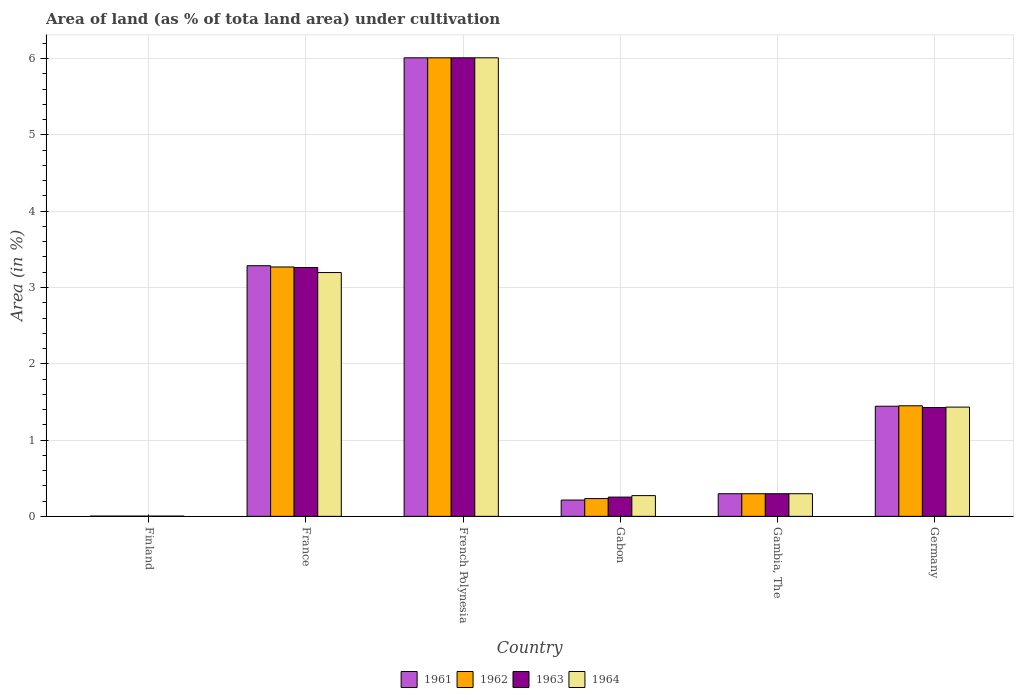What is the label of the 4th group of bars from the left?
Provide a succinct answer. Gabon. In how many cases, is the number of bars for a given country not equal to the number of legend labels?
Keep it short and to the point. 0. What is the percentage of land under cultivation in 1962 in French Polynesia?
Ensure brevity in your answer.  6.01. Across all countries, what is the maximum percentage of land under cultivation in 1964?
Provide a succinct answer. 6.01. Across all countries, what is the minimum percentage of land under cultivation in 1963?
Give a very brief answer. 0. In which country was the percentage of land under cultivation in 1961 maximum?
Provide a succinct answer. French Polynesia. In which country was the percentage of land under cultivation in 1964 minimum?
Give a very brief answer. Finland. What is the total percentage of land under cultivation in 1961 in the graph?
Provide a short and direct response. 11.25. What is the difference between the percentage of land under cultivation in 1961 in French Polynesia and that in Germany?
Offer a terse response. 4.57. What is the difference between the percentage of land under cultivation in 1962 in Finland and the percentage of land under cultivation in 1964 in French Polynesia?
Offer a terse response. -6.01. What is the average percentage of land under cultivation in 1962 per country?
Provide a short and direct response. 1.88. In how many countries, is the percentage of land under cultivation in 1961 greater than 0.2 %?
Offer a terse response. 5. What is the ratio of the percentage of land under cultivation in 1961 in Finland to that in Germany?
Your answer should be very brief. 0. Is the difference between the percentage of land under cultivation in 1964 in France and Germany greater than the difference between the percentage of land under cultivation in 1963 in France and Germany?
Offer a very short reply. No. What is the difference between the highest and the second highest percentage of land under cultivation in 1961?
Provide a short and direct response. -1.84. What is the difference between the highest and the lowest percentage of land under cultivation in 1961?
Offer a very short reply. 6.01. How many bars are there?
Keep it short and to the point. 24. Are all the bars in the graph horizontal?
Your answer should be very brief. No. How many countries are there in the graph?
Your response must be concise. 6. Does the graph contain any zero values?
Your response must be concise. No. How many legend labels are there?
Your answer should be compact. 4. What is the title of the graph?
Offer a very short reply. Area of land (as % of tota land area) under cultivation. Does "2013" appear as one of the legend labels in the graph?
Your answer should be compact. No. What is the label or title of the Y-axis?
Offer a very short reply. Area (in %). What is the Area (in %) of 1961 in Finland?
Your response must be concise. 0. What is the Area (in %) of 1962 in Finland?
Offer a very short reply. 0. What is the Area (in %) of 1963 in Finland?
Make the answer very short. 0. What is the Area (in %) in 1964 in Finland?
Give a very brief answer. 0. What is the Area (in %) in 1961 in France?
Provide a succinct answer. 3.29. What is the Area (in %) in 1962 in France?
Give a very brief answer. 3.27. What is the Area (in %) in 1963 in France?
Your response must be concise. 3.26. What is the Area (in %) of 1964 in France?
Your answer should be very brief. 3.2. What is the Area (in %) in 1961 in French Polynesia?
Offer a very short reply. 6.01. What is the Area (in %) in 1962 in French Polynesia?
Your answer should be very brief. 6.01. What is the Area (in %) of 1963 in French Polynesia?
Give a very brief answer. 6.01. What is the Area (in %) in 1964 in French Polynesia?
Give a very brief answer. 6.01. What is the Area (in %) in 1961 in Gabon?
Ensure brevity in your answer.  0.21. What is the Area (in %) of 1962 in Gabon?
Your response must be concise. 0.23. What is the Area (in %) of 1963 in Gabon?
Your response must be concise. 0.25. What is the Area (in %) of 1964 in Gabon?
Make the answer very short. 0.27. What is the Area (in %) of 1961 in Gambia, The?
Your answer should be compact. 0.3. What is the Area (in %) in 1962 in Gambia, The?
Your response must be concise. 0.3. What is the Area (in %) of 1963 in Gambia, The?
Your answer should be compact. 0.3. What is the Area (in %) of 1964 in Gambia, The?
Make the answer very short. 0.3. What is the Area (in %) in 1961 in Germany?
Offer a very short reply. 1.44. What is the Area (in %) of 1962 in Germany?
Provide a succinct answer. 1.45. What is the Area (in %) in 1963 in Germany?
Your answer should be very brief. 1.43. What is the Area (in %) in 1964 in Germany?
Ensure brevity in your answer.  1.43. Across all countries, what is the maximum Area (in %) in 1961?
Provide a succinct answer. 6.01. Across all countries, what is the maximum Area (in %) of 1962?
Give a very brief answer. 6.01. Across all countries, what is the maximum Area (in %) in 1963?
Make the answer very short. 6.01. Across all countries, what is the maximum Area (in %) of 1964?
Give a very brief answer. 6.01. Across all countries, what is the minimum Area (in %) in 1961?
Make the answer very short. 0. Across all countries, what is the minimum Area (in %) in 1962?
Offer a very short reply. 0. Across all countries, what is the minimum Area (in %) in 1963?
Keep it short and to the point. 0. Across all countries, what is the minimum Area (in %) of 1964?
Make the answer very short. 0. What is the total Area (in %) of 1961 in the graph?
Your answer should be very brief. 11.25. What is the total Area (in %) in 1962 in the graph?
Offer a terse response. 11.26. What is the total Area (in %) of 1963 in the graph?
Offer a terse response. 11.25. What is the total Area (in %) in 1964 in the graph?
Make the answer very short. 11.21. What is the difference between the Area (in %) in 1961 in Finland and that in France?
Offer a terse response. -3.28. What is the difference between the Area (in %) of 1962 in Finland and that in France?
Your answer should be very brief. -3.27. What is the difference between the Area (in %) in 1963 in Finland and that in France?
Offer a very short reply. -3.26. What is the difference between the Area (in %) of 1964 in Finland and that in France?
Your answer should be compact. -3.19. What is the difference between the Area (in %) in 1961 in Finland and that in French Polynesia?
Your response must be concise. -6.01. What is the difference between the Area (in %) in 1962 in Finland and that in French Polynesia?
Your response must be concise. -6.01. What is the difference between the Area (in %) in 1963 in Finland and that in French Polynesia?
Ensure brevity in your answer.  -6.01. What is the difference between the Area (in %) in 1964 in Finland and that in French Polynesia?
Give a very brief answer. -6.01. What is the difference between the Area (in %) of 1961 in Finland and that in Gabon?
Make the answer very short. -0.21. What is the difference between the Area (in %) in 1962 in Finland and that in Gabon?
Provide a succinct answer. -0.23. What is the difference between the Area (in %) of 1963 in Finland and that in Gabon?
Provide a short and direct response. -0.25. What is the difference between the Area (in %) in 1964 in Finland and that in Gabon?
Offer a very short reply. -0.27. What is the difference between the Area (in %) of 1961 in Finland and that in Gambia, The?
Your answer should be compact. -0.29. What is the difference between the Area (in %) in 1962 in Finland and that in Gambia, The?
Provide a succinct answer. -0.29. What is the difference between the Area (in %) of 1963 in Finland and that in Gambia, The?
Keep it short and to the point. -0.29. What is the difference between the Area (in %) in 1964 in Finland and that in Gambia, The?
Your answer should be very brief. -0.29. What is the difference between the Area (in %) of 1961 in Finland and that in Germany?
Provide a succinct answer. -1.44. What is the difference between the Area (in %) of 1962 in Finland and that in Germany?
Provide a short and direct response. -1.45. What is the difference between the Area (in %) of 1963 in Finland and that in Germany?
Give a very brief answer. -1.42. What is the difference between the Area (in %) of 1964 in Finland and that in Germany?
Ensure brevity in your answer.  -1.43. What is the difference between the Area (in %) in 1961 in France and that in French Polynesia?
Give a very brief answer. -2.73. What is the difference between the Area (in %) in 1962 in France and that in French Polynesia?
Your response must be concise. -2.74. What is the difference between the Area (in %) in 1963 in France and that in French Polynesia?
Offer a terse response. -2.75. What is the difference between the Area (in %) in 1964 in France and that in French Polynesia?
Your answer should be very brief. -2.81. What is the difference between the Area (in %) in 1961 in France and that in Gabon?
Keep it short and to the point. 3.07. What is the difference between the Area (in %) in 1962 in France and that in Gabon?
Give a very brief answer. 3.04. What is the difference between the Area (in %) in 1963 in France and that in Gabon?
Ensure brevity in your answer.  3.01. What is the difference between the Area (in %) of 1964 in France and that in Gabon?
Give a very brief answer. 2.92. What is the difference between the Area (in %) in 1961 in France and that in Gambia, The?
Your answer should be compact. 2.99. What is the difference between the Area (in %) of 1962 in France and that in Gambia, The?
Provide a short and direct response. 2.97. What is the difference between the Area (in %) in 1963 in France and that in Gambia, The?
Ensure brevity in your answer.  2.97. What is the difference between the Area (in %) of 1964 in France and that in Gambia, The?
Your response must be concise. 2.9. What is the difference between the Area (in %) in 1961 in France and that in Germany?
Your response must be concise. 1.84. What is the difference between the Area (in %) of 1962 in France and that in Germany?
Your answer should be compact. 1.82. What is the difference between the Area (in %) of 1963 in France and that in Germany?
Provide a short and direct response. 1.84. What is the difference between the Area (in %) of 1964 in France and that in Germany?
Offer a very short reply. 1.76. What is the difference between the Area (in %) of 1961 in French Polynesia and that in Gabon?
Your answer should be compact. 5.8. What is the difference between the Area (in %) of 1962 in French Polynesia and that in Gabon?
Provide a succinct answer. 5.78. What is the difference between the Area (in %) in 1963 in French Polynesia and that in Gabon?
Keep it short and to the point. 5.76. What is the difference between the Area (in %) of 1964 in French Polynesia and that in Gabon?
Make the answer very short. 5.74. What is the difference between the Area (in %) in 1961 in French Polynesia and that in Gambia, The?
Ensure brevity in your answer.  5.71. What is the difference between the Area (in %) in 1962 in French Polynesia and that in Gambia, The?
Provide a short and direct response. 5.71. What is the difference between the Area (in %) of 1963 in French Polynesia and that in Gambia, The?
Your response must be concise. 5.71. What is the difference between the Area (in %) of 1964 in French Polynesia and that in Gambia, The?
Provide a short and direct response. 5.71. What is the difference between the Area (in %) of 1961 in French Polynesia and that in Germany?
Ensure brevity in your answer.  4.57. What is the difference between the Area (in %) in 1962 in French Polynesia and that in Germany?
Your answer should be compact. 4.56. What is the difference between the Area (in %) of 1963 in French Polynesia and that in Germany?
Provide a short and direct response. 4.58. What is the difference between the Area (in %) in 1964 in French Polynesia and that in Germany?
Provide a succinct answer. 4.58. What is the difference between the Area (in %) in 1961 in Gabon and that in Gambia, The?
Give a very brief answer. -0.08. What is the difference between the Area (in %) in 1962 in Gabon and that in Gambia, The?
Offer a terse response. -0.06. What is the difference between the Area (in %) of 1963 in Gabon and that in Gambia, The?
Your answer should be very brief. -0.04. What is the difference between the Area (in %) in 1964 in Gabon and that in Gambia, The?
Offer a terse response. -0.02. What is the difference between the Area (in %) in 1961 in Gabon and that in Germany?
Provide a succinct answer. -1.23. What is the difference between the Area (in %) of 1962 in Gabon and that in Germany?
Offer a very short reply. -1.22. What is the difference between the Area (in %) in 1963 in Gabon and that in Germany?
Give a very brief answer. -1.17. What is the difference between the Area (in %) of 1964 in Gabon and that in Germany?
Your response must be concise. -1.16. What is the difference between the Area (in %) of 1961 in Gambia, The and that in Germany?
Your answer should be very brief. -1.15. What is the difference between the Area (in %) in 1962 in Gambia, The and that in Germany?
Your answer should be compact. -1.15. What is the difference between the Area (in %) in 1963 in Gambia, The and that in Germany?
Keep it short and to the point. -1.13. What is the difference between the Area (in %) in 1964 in Gambia, The and that in Germany?
Your answer should be compact. -1.14. What is the difference between the Area (in %) of 1961 in Finland and the Area (in %) of 1962 in France?
Keep it short and to the point. -3.27. What is the difference between the Area (in %) of 1961 in Finland and the Area (in %) of 1963 in France?
Offer a terse response. -3.26. What is the difference between the Area (in %) in 1961 in Finland and the Area (in %) in 1964 in France?
Your response must be concise. -3.19. What is the difference between the Area (in %) of 1962 in Finland and the Area (in %) of 1963 in France?
Give a very brief answer. -3.26. What is the difference between the Area (in %) of 1962 in Finland and the Area (in %) of 1964 in France?
Provide a short and direct response. -3.19. What is the difference between the Area (in %) of 1963 in Finland and the Area (in %) of 1964 in France?
Give a very brief answer. -3.19. What is the difference between the Area (in %) of 1961 in Finland and the Area (in %) of 1962 in French Polynesia?
Give a very brief answer. -6.01. What is the difference between the Area (in %) of 1961 in Finland and the Area (in %) of 1963 in French Polynesia?
Your answer should be very brief. -6.01. What is the difference between the Area (in %) of 1961 in Finland and the Area (in %) of 1964 in French Polynesia?
Offer a terse response. -6.01. What is the difference between the Area (in %) of 1962 in Finland and the Area (in %) of 1963 in French Polynesia?
Your answer should be compact. -6.01. What is the difference between the Area (in %) of 1962 in Finland and the Area (in %) of 1964 in French Polynesia?
Provide a short and direct response. -6.01. What is the difference between the Area (in %) of 1963 in Finland and the Area (in %) of 1964 in French Polynesia?
Your answer should be very brief. -6.01. What is the difference between the Area (in %) in 1961 in Finland and the Area (in %) in 1962 in Gabon?
Ensure brevity in your answer.  -0.23. What is the difference between the Area (in %) in 1961 in Finland and the Area (in %) in 1963 in Gabon?
Make the answer very short. -0.25. What is the difference between the Area (in %) of 1961 in Finland and the Area (in %) of 1964 in Gabon?
Ensure brevity in your answer.  -0.27. What is the difference between the Area (in %) of 1962 in Finland and the Area (in %) of 1963 in Gabon?
Provide a short and direct response. -0.25. What is the difference between the Area (in %) of 1962 in Finland and the Area (in %) of 1964 in Gabon?
Your response must be concise. -0.27. What is the difference between the Area (in %) of 1963 in Finland and the Area (in %) of 1964 in Gabon?
Provide a short and direct response. -0.27. What is the difference between the Area (in %) in 1961 in Finland and the Area (in %) in 1962 in Gambia, The?
Make the answer very short. -0.29. What is the difference between the Area (in %) in 1961 in Finland and the Area (in %) in 1963 in Gambia, The?
Your answer should be compact. -0.29. What is the difference between the Area (in %) in 1961 in Finland and the Area (in %) in 1964 in Gambia, The?
Provide a succinct answer. -0.29. What is the difference between the Area (in %) in 1962 in Finland and the Area (in %) in 1963 in Gambia, The?
Your answer should be very brief. -0.29. What is the difference between the Area (in %) in 1962 in Finland and the Area (in %) in 1964 in Gambia, The?
Offer a terse response. -0.29. What is the difference between the Area (in %) of 1963 in Finland and the Area (in %) of 1964 in Gambia, The?
Your answer should be very brief. -0.29. What is the difference between the Area (in %) of 1961 in Finland and the Area (in %) of 1962 in Germany?
Keep it short and to the point. -1.45. What is the difference between the Area (in %) in 1961 in Finland and the Area (in %) in 1963 in Germany?
Provide a short and direct response. -1.42. What is the difference between the Area (in %) in 1961 in Finland and the Area (in %) in 1964 in Germany?
Ensure brevity in your answer.  -1.43. What is the difference between the Area (in %) of 1962 in Finland and the Area (in %) of 1963 in Germany?
Keep it short and to the point. -1.42. What is the difference between the Area (in %) in 1962 in Finland and the Area (in %) in 1964 in Germany?
Make the answer very short. -1.43. What is the difference between the Area (in %) of 1963 in Finland and the Area (in %) of 1964 in Germany?
Your response must be concise. -1.43. What is the difference between the Area (in %) of 1961 in France and the Area (in %) of 1962 in French Polynesia?
Offer a terse response. -2.73. What is the difference between the Area (in %) in 1961 in France and the Area (in %) in 1963 in French Polynesia?
Keep it short and to the point. -2.73. What is the difference between the Area (in %) in 1961 in France and the Area (in %) in 1964 in French Polynesia?
Your response must be concise. -2.73. What is the difference between the Area (in %) of 1962 in France and the Area (in %) of 1963 in French Polynesia?
Your response must be concise. -2.74. What is the difference between the Area (in %) in 1962 in France and the Area (in %) in 1964 in French Polynesia?
Your response must be concise. -2.74. What is the difference between the Area (in %) of 1963 in France and the Area (in %) of 1964 in French Polynesia?
Your response must be concise. -2.75. What is the difference between the Area (in %) of 1961 in France and the Area (in %) of 1962 in Gabon?
Give a very brief answer. 3.05. What is the difference between the Area (in %) of 1961 in France and the Area (in %) of 1963 in Gabon?
Your answer should be very brief. 3.03. What is the difference between the Area (in %) in 1961 in France and the Area (in %) in 1964 in Gabon?
Your answer should be compact. 3.01. What is the difference between the Area (in %) in 1962 in France and the Area (in %) in 1963 in Gabon?
Offer a terse response. 3.02. What is the difference between the Area (in %) of 1962 in France and the Area (in %) of 1964 in Gabon?
Your response must be concise. 3. What is the difference between the Area (in %) of 1963 in France and the Area (in %) of 1964 in Gabon?
Offer a very short reply. 2.99. What is the difference between the Area (in %) of 1961 in France and the Area (in %) of 1962 in Gambia, The?
Keep it short and to the point. 2.99. What is the difference between the Area (in %) in 1961 in France and the Area (in %) in 1963 in Gambia, The?
Make the answer very short. 2.99. What is the difference between the Area (in %) in 1961 in France and the Area (in %) in 1964 in Gambia, The?
Offer a terse response. 2.99. What is the difference between the Area (in %) in 1962 in France and the Area (in %) in 1963 in Gambia, The?
Provide a succinct answer. 2.97. What is the difference between the Area (in %) in 1962 in France and the Area (in %) in 1964 in Gambia, The?
Your answer should be compact. 2.97. What is the difference between the Area (in %) in 1963 in France and the Area (in %) in 1964 in Gambia, The?
Your response must be concise. 2.97. What is the difference between the Area (in %) of 1961 in France and the Area (in %) of 1962 in Germany?
Offer a terse response. 1.84. What is the difference between the Area (in %) of 1961 in France and the Area (in %) of 1963 in Germany?
Make the answer very short. 1.86. What is the difference between the Area (in %) of 1961 in France and the Area (in %) of 1964 in Germany?
Your answer should be compact. 1.85. What is the difference between the Area (in %) of 1962 in France and the Area (in %) of 1963 in Germany?
Your answer should be very brief. 1.84. What is the difference between the Area (in %) of 1962 in France and the Area (in %) of 1964 in Germany?
Offer a very short reply. 1.84. What is the difference between the Area (in %) in 1963 in France and the Area (in %) in 1964 in Germany?
Provide a short and direct response. 1.83. What is the difference between the Area (in %) of 1961 in French Polynesia and the Area (in %) of 1962 in Gabon?
Keep it short and to the point. 5.78. What is the difference between the Area (in %) of 1961 in French Polynesia and the Area (in %) of 1963 in Gabon?
Provide a short and direct response. 5.76. What is the difference between the Area (in %) of 1961 in French Polynesia and the Area (in %) of 1964 in Gabon?
Your answer should be very brief. 5.74. What is the difference between the Area (in %) of 1962 in French Polynesia and the Area (in %) of 1963 in Gabon?
Keep it short and to the point. 5.76. What is the difference between the Area (in %) of 1962 in French Polynesia and the Area (in %) of 1964 in Gabon?
Your answer should be very brief. 5.74. What is the difference between the Area (in %) of 1963 in French Polynesia and the Area (in %) of 1964 in Gabon?
Keep it short and to the point. 5.74. What is the difference between the Area (in %) in 1961 in French Polynesia and the Area (in %) in 1962 in Gambia, The?
Give a very brief answer. 5.71. What is the difference between the Area (in %) of 1961 in French Polynesia and the Area (in %) of 1963 in Gambia, The?
Make the answer very short. 5.71. What is the difference between the Area (in %) in 1961 in French Polynesia and the Area (in %) in 1964 in Gambia, The?
Provide a succinct answer. 5.71. What is the difference between the Area (in %) of 1962 in French Polynesia and the Area (in %) of 1963 in Gambia, The?
Provide a short and direct response. 5.71. What is the difference between the Area (in %) of 1962 in French Polynesia and the Area (in %) of 1964 in Gambia, The?
Provide a succinct answer. 5.71. What is the difference between the Area (in %) of 1963 in French Polynesia and the Area (in %) of 1964 in Gambia, The?
Provide a succinct answer. 5.71. What is the difference between the Area (in %) in 1961 in French Polynesia and the Area (in %) in 1962 in Germany?
Ensure brevity in your answer.  4.56. What is the difference between the Area (in %) in 1961 in French Polynesia and the Area (in %) in 1963 in Germany?
Provide a succinct answer. 4.58. What is the difference between the Area (in %) in 1961 in French Polynesia and the Area (in %) in 1964 in Germany?
Ensure brevity in your answer.  4.58. What is the difference between the Area (in %) of 1962 in French Polynesia and the Area (in %) of 1963 in Germany?
Ensure brevity in your answer.  4.58. What is the difference between the Area (in %) of 1962 in French Polynesia and the Area (in %) of 1964 in Germany?
Provide a short and direct response. 4.58. What is the difference between the Area (in %) of 1963 in French Polynesia and the Area (in %) of 1964 in Germany?
Ensure brevity in your answer.  4.58. What is the difference between the Area (in %) of 1961 in Gabon and the Area (in %) of 1962 in Gambia, The?
Your answer should be compact. -0.08. What is the difference between the Area (in %) of 1961 in Gabon and the Area (in %) of 1963 in Gambia, The?
Offer a very short reply. -0.08. What is the difference between the Area (in %) of 1961 in Gabon and the Area (in %) of 1964 in Gambia, The?
Keep it short and to the point. -0.08. What is the difference between the Area (in %) in 1962 in Gabon and the Area (in %) in 1963 in Gambia, The?
Offer a terse response. -0.06. What is the difference between the Area (in %) of 1962 in Gabon and the Area (in %) of 1964 in Gambia, The?
Give a very brief answer. -0.06. What is the difference between the Area (in %) in 1963 in Gabon and the Area (in %) in 1964 in Gambia, The?
Make the answer very short. -0.04. What is the difference between the Area (in %) in 1961 in Gabon and the Area (in %) in 1962 in Germany?
Ensure brevity in your answer.  -1.24. What is the difference between the Area (in %) in 1961 in Gabon and the Area (in %) in 1963 in Germany?
Your answer should be very brief. -1.21. What is the difference between the Area (in %) in 1961 in Gabon and the Area (in %) in 1964 in Germany?
Keep it short and to the point. -1.22. What is the difference between the Area (in %) of 1962 in Gabon and the Area (in %) of 1963 in Germany?
Your response must be concise. -1.19. What is the difference between the Area (in %) in 1962 in Gabon and the Area (in %) in 1964 in Germany?
Make the answer very short. -1.2. What is the difference between the Area (in %) in 1963 in Gabon and the Area (in %) in 1964 in Germany?
Give a very brief answer. -1.18. What is the difference between the Area (in %) of 1961 in Gambia, The and the Area (in %) of 1962 in Germany?
Offer a very short reply. -1.15. What is the difference between the Area (in %) in 1961 in Gambia, The and the Area (in %) in 1963 in Germany?
Give a very brief answer. -1.13. What is the difference between the Area (in %) in 1961 in Gambia, The and the Area (in %) in 1964 in Germany?
Your answer should be compact. -1.14. What is the difference between the Area (in %) of 1962 in Gambia, The and the Area (in %) of 1963 in Germany?
Offer a terse response. -1.13. What is the difference between the Area (in %) of 1962 in Gambia, The and the Area (in %) of 1964 in Germany?
Offer a very short reply. -1.14. What is the difference between the Area (in %) in 1963 in Gambia, The and the Area (in %) in 1964 in Germany?
Your answer should be compact. -1.14. What is the average Area (in %) of 1961 per country?
Your answer should be very brief. 1.88. What is the average Area (in %) of 1962 per country?
Your answer should be very brief. 1.88. What is the average Area (in %) of 1963 per country?
Offer a very short reply. 1.88. What is the average Area (in %) in 1964 per country?
Make the answer very short. 1.87. What is the difference between the Area (in %) in 1961 and Area (in %) in 1962 in Finland?
Ensure brevity in your answer.  0. What is the difference between the Area (in %) in 1962 and Area (in %) in 1963 in Finland?
Offer a very short reply. 0. What is the difference between the Area (in %) of 1963 and Area (in %) of 1964 in Finland?
Provide a succinct answer. 0. What is the difference between the Area (in %) in 1961 and Area (in %) in 1962 in France?
Provide a short and direct response. 0.02. What is the difference between the Area (in %) in 1961 and Area (in %) in 1963 in France?
Make the answer very short. 0.02. What is the difference between the Area (in %) of 1961 and Area (in %) of 1964 in France?
Your answer should be very brief. 0.09. What is the difference between the Area (in %) in 1962 and Area (in %) in 1963 in France?
Offer a terse response. 0.01. What is the difference between the Area (in %) in 1962 and Area (in %) in 1964 in France?
Give a very brief answer. 0.07. What is the difference between the Area (in %) in 1963 and Area (in %) in 1964 in France?
Ensure brevity in your answer.  0.07. What is the difference between the Area (in %) in 1961 and Area (in %) in 1964 in French Polynesia?
Your answer should be compact. 0. What is the difference between the Area (in %) of 1962 and Area (in %) of 1963 in French Polynesia?
Your response must be concise. 0. What is the difference between the Area (in %) of 1961 and Area (in %) of 1962 in Gabon?
Your answer should be compact. -0.02. What is the difference between the Area (in %) of 1961 and Area (in %) of 1963 in Gabon?
Provide a succinct answer. -0.04. What is the difference between the Area (in %) in 1961 and Area (in %) in 1964 in Gabon?
Offer a terse response. -0.06. What is the difference between the Area (in %) of 1962 and Area (in %) of 1963 in Gabon?
Provide a succinct answer. -0.02. What is the difference between the Area (in %) in 1962 and Area (in %) in 1964 in Gabon?
Your answer should be very brief. -0.04. What is the difference between the Area (in %) of 1963 and Area (in %) of 1964 in Gabon?
Give a very brief answer. -0.02. What is the difference between the Area (in %) in 1961 and Area (in %) in 1962 in Gambia, The?
Your answer should be compact. 0. What is the difference between the Area (in %) in 1961 and Area (in %) in 1963 in Gambia, The?
Give a very brief answer. 0. What is the difference between the Area (in %) of 1961 and Area (in %) of 1964 in Gambia, The?
Make the answer very short. 0. What is the difference between the Area (in %) of 1962 and Area (in %) of 1963 in Gambia, The?
Keep it short and to the point. 0. What is the difference between the Area (in %) in 1962 and Area (in %) in 1964 in Gambia, The?
Give a very brief answer. 0. What is the difference between the Area (in %) of 1963 and Area (in %) of 1964 in Gambia, The?
Provide a succinct answer. 0. What is the difference between the Area (in %) of 1961 and Area (in %) of 1962 in Germany?
Offer a very short reply. -0.01. What is the difference between the Area (in %) of 1961 and Area (in %) of 1963 in Germany?
Provide a short and direct response. 0.02. What is the difference between the Area (in %) of 1961 and Area (in %) of 1964 in Germany?
Keep it short and to the point. 0.01. What is the difference between the Area (in %) of 1962 and Area (in %) of 1963 in Germany?
Offer a very short reply. 0.02. What is the difference between the Area (in %) of 1962 and Area (in %) of 1964 in Germany?
Offer a very short reply. 0.02. What is the difference between the Area (in %) of 1963 and Area (in %) of 1964 in Germany?
Offer a terse response. -0.01. What is the ratio of the Area (in %) in 1962 in Finland to that in France?
Offer a very short reply. 0. What is the ratio of the Area (in %) of 1963 in Finland to that in France?
Provide a succinct answer. 0. What is the ratio of the Area (in %) in 1961 in Finland to that in French Polynesia?
Make the answer very short. 0. What is the ratio of the Area (in %) of 1962 in Finland to that in French Polynesia?
Your answer should be very brief. 0. What is the ratio of the Area (in %) of 1963 in Finland to that in French Polynesia?
Make the answer very short. 0. What is the ratio of the Area (in %) of 1961 in Finland to that in Gabon?
Give a very brief answer. 0.02. What is the ratio of the Area (in %) of 1962 in Finland to that in Gabon?
Make the answer very short. 0.01. What is the ratio of the Area (in %) of 1963 in Finland to that in Gabon?
Make the answer very short. 0.01. What is the ratio of the Area (in %) in 1964 in Finland to that in Gabon?
Your answer should be very brief. 0.01. What is the ratio of the Area (in %) of 1961 in Finland to that in Gambia, The?
Make the answer very short. 0.01. What is the ratio of the Area (in %) of 1962 in Finland to that in Gambia, The?
Make the answer very short. 0.01. What is the ratio of the Area (in %) of 1963 in Finland to that in Gambia, The?
Keep it short and to the point. 0.01. What is the ratio of the Area (in %) of 1964 in Finland to that in Gambia, The?
Provide a short and direct response. 0.01. What is the ratio of the Area (in %) in 1961 in Finland to that in Germany?
Provide a short and direct response. 0. What is the ratio of the Area (in %) in 1962 in Finland to that in Germany?
Your answer should be very brief. 0. What is the ratio of the Area (in %) of 1963 in Finland to that in Germany?
Offer a very short reply. 0. What is the ratio of the Area (in %) of 1964 in Finland to that in Germany?
Ensure brevity in your answer.  0. What is the ratio of the Area (in %) of 1961 in France to that in French Polynesia?
Keep it short and to the point. 0.55. What is the ratio of the Area (in %) in 1962 in France to that in French Polynesia?
Ensure brevity in your answer.  0.54. What is the ratio of the Area (in %) of 1963 in France to that in French Polynesia?
Your answer should be compact. 0.54. What is the ratio of the Area (in %) in 1964 in France to that in French Polynesia?
Make the answer very short. 0.53. What is the ratio of the Area (in %) of 1961 in France to that in Gabon?
Offer a very short reply. 15.39. What is the ratio of the Area (in %) of 1962 in France to that in Gabon?
Offer a terse response. 14.04. What is the ratio of the Area (in %) in 1963 in France to that in Gabon?
Your answer should be very brief. 12.93. What is the ratio of the Area (in %) in 1964 in France to that in Gabon?
Provide a short and direct response. 11.76. What is the ratio of the Area (in %) in 1961 in France to that in Gambia, The?
Keep it short and to the point. 11.08. What is the ratio of the Area (in %) in 1962 in France to that in Gambia, The?
Offer a very short reply. 11.03. What is the ratio of the Area (in %) in 1963 in France to that in Gambia, The?
Ensure brevity in your answer.  11. What is the ratio of the Area (in %) in 1964 in France to that in Gambia, The?
Make the answer very short. 10.78. What is the ratio of the Area (in %) in 1961 in France to that in Germany?
Offer a terse response. 2.28. What is the ratio of the Area (in %) of 1962 in France to that in Germany?
Keep it short and to the point. 2.26. What is the ratio of the Area (in %) of 1963 in France to that in Germany?
Provide a succinct answer. 2.29. What is the ratio of the Area (in %) in 1964 in France to that in Germany?
Make the answer very short. 2.23. What is the ratio of the Area (in %) in 1961 in French Polynesia to that in Gabon?
Offer a very short reply. 28.16. What is the ratio of the Area (in %) of 1962 in French Polynesia to that in Gabon?
Ensure brevity in your answer.  25.81. What is the ratio of the Area (in %) in 1963 in French Polynesia to that in Gabon?
Your response must be concise. 23.83. What is the ratio of the Area (in %) in 1964 in French Polynesia to that in Gabon?
Keep it short and to the point. 22.13. What is the ratio of the Area (in %) in 1961 in French Polynesia to that in Gambia, The?
Your response must be concise. 20.28. What is the ratio of the Area (in %) of 1962 in French Polynesia to that in Gambia, The?
Your answer should be very brief. 20.28. What is the ratio of the Area (in %) of 1963 in French Polynesia to that in Gambia, The?
Provide a succinct answer. 20.28. What is the ratio of the Area (in %) in 1964 in French Polynesia to that in Gambia, The?
Give a very brief answer. 20.28. What is the ratio of the Area (in %) in 1961 in French Polynesia to that in Germany?
Offer a very short reply. 4.16. What is the ratio of the Area (in %) of 1962 in French Polynesia to that in Germany?
Offer a very short reply. 4.15. What is the ratio of the Area (in %) in 1963 in French Polynesia to that in Germany?
Offer a very short reply. 4.21. What is the ratio of the Area (in %) in 1964 in French Polynesia to that in Germany?
Your answer should be compact. 4.2. What is the ratio of the Area (in %) of 1961 in Gabon to that in Gambia, The?
Your answer should be compact. 0.72. What is the ratio of the Area (in %) in 1962 in Gabon to that in Gambia, The?
Offer a terse response. 0.79. What is the ratio of the Area (in %) of 1963 in Gabon to that in Gambia, The?
Keep it short and to the point. 0.85. What is the ratio of the Area (in %) of 1964 in Gabon to that in Gambia, The?
Offer a very short reply. 0.92. What is the ratio of the Area (in %) in 1961 in Gabon to that in Germany?
Your answer should be compact. 0.15. What is the ratio of the Area (in %) in 1962 in Gabon to that in Germany?
Give a very brief answer. 0.16. What is the ratio of the Area (in %) of 1963 in Gabon to that in Germany?
Offer a terse response. 0.18. What is the ratio of the Area (in %) in 1964 in Gabon to that in Germany?
Keep it short and to the point. 0.19. What is the ratio of the Area (in %) of 1961 in Gambia, The to that in Germany?
Provide a succinct answer. 0.21. What is the ratio of the Area (in %) in 1962 in Gambia, The to that in Germany?
Your response must be concise. 0.2. What is the ratio of the Area (in %) in 1963 in Gambia, The to that in Germany?
Provide a short and direct response. 0.21. What is the ratio of the Area (in %) in 1964 in Gambia, The to that in Germany?
Make the answer very short. 0.21. What is the difference between the highest and the second highest Area (in %) in 1961?
Offer a very short reply. 2.73. What is the difference between the highest and the second highest Area (in %) in 1962?
Keep it short and to the point. 2.74. What is the difference between the highest and the second highest Area (in %) in 1963?
Ensure brevity in your answer.  2.75. What is the difference between the highest and the second highest Area (in %) in 1964?
Provide a succinct answer. 2.81. What is the difference between the highest and the lowest Area (in %) of 1961?
Provide a short and direct response. 6.01. What is the difference between the highest and the lowest Area (in %) of 1962?
Your answer should be compact. 6.01. What is the difference between the highest and the lowest Area (in %) of 1963?
Your response must be concise. 6.01. What is the difference between the highest and the lowest Area (in %) in 1964?
Provide a short and direct response. 6.01. 